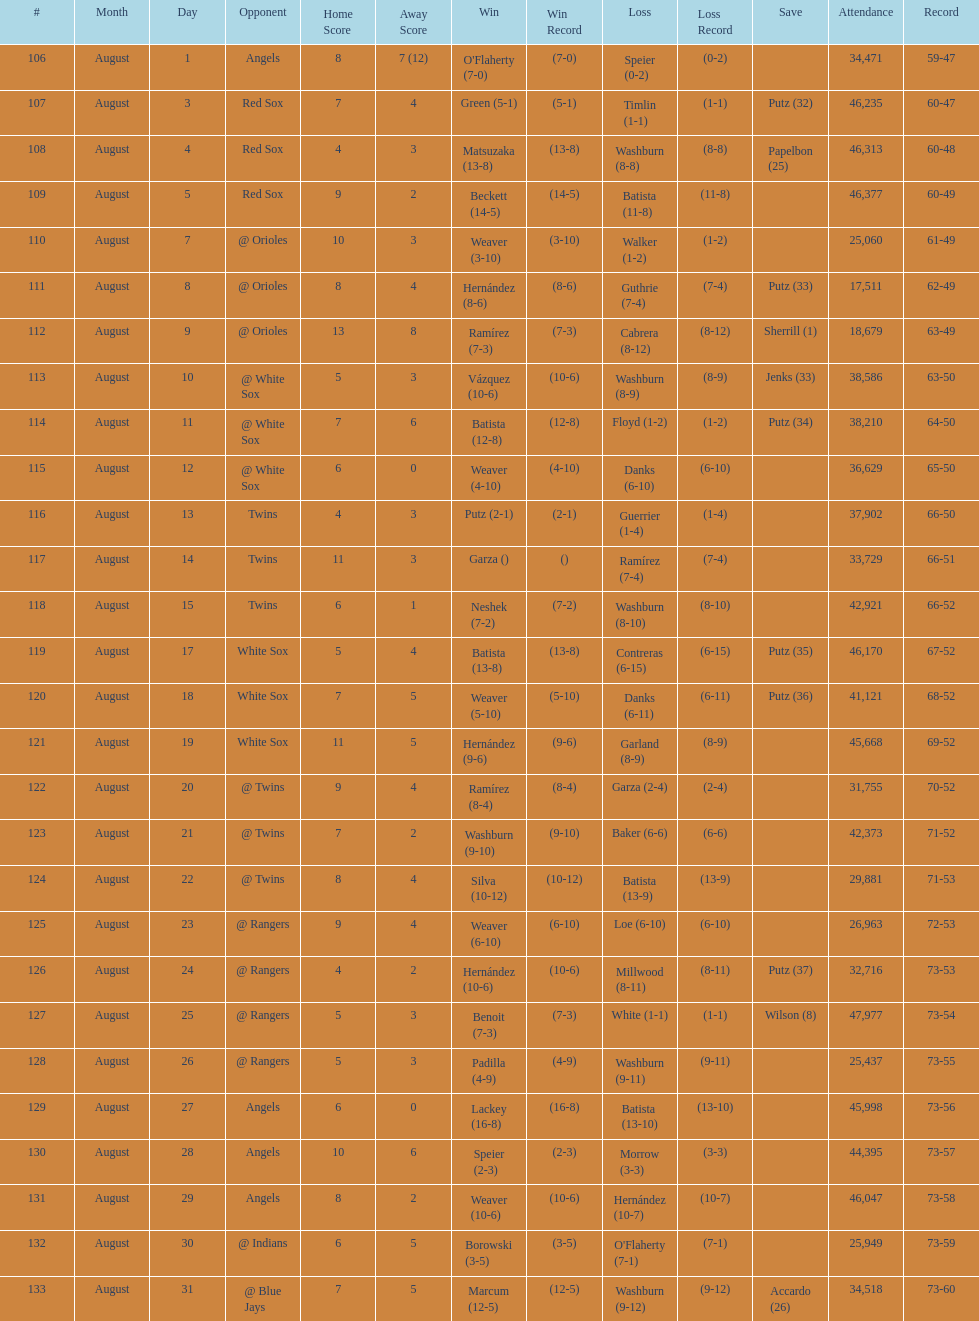Can you give me this table as a dict? {'header': ['#', 'Month', 'Day', 'Opponent', 'Home Score', 'Away Score', 'Win', 'Win Record', 'Loss', 'Loss Record', 'Save', 'Attendance', 'Record'], 'rows': [['106', 'August', '1', 'Angels', '8', '7 (12)', "O'Flaherty (7-0)", '(7-0)', 'Speier (0-2)', '(0-2)', '', '34,471', '59-47'], ['107', 'August', '3', 'Red Sox', '7', '4', 'Green (5-1)', '(5-1)', 'Timlin (1-1)', '(1-1)', 'Putz (32)', '46,235', '60-47'], ['108', 'August', '4', 'Red Sox', '4', '3', 'Matsuzaka (13-8)', '(13-8)', 'Washburn (8-8)', '(8-8)', 'Papelbon (25)', '46,313', '60-48'], ['109', 'August', '5', 'Red Sox', '9', '2', 'Beckett (14-5)', '(14-5)', 'Batista (11-8)', '(11-8)', '', '46,377', '60-49'], ['110', 'August', '7', '@ Orioles', '10', '3', 'Weaver (3-10)', '(3-10)', 'Walker (1-2)', '(1-2)', '', '25,060', '61-49'], ['111', 'August', '8', '@ Orioles', '8', '4', 'Hernández (8-6)', '(8-6)', 'Guthrie (7-4)', '(7-4)', 'Putz (33)', '17,511', '62-49'], ['112', 'August', '9', '@ Orioles', '13', '8', 'Ramírez (7-3)', '(7-3)', 'Cabrera (8-12)', '(8-12)', 'Sherrill (1)', '18,679', '63-49'], ['113', 'August', '10', '@ White Sox', '5', '3', 'Vázquez (10-6)', '(10-6)', 'Washburn (8-9)', '(8-9)', 'Jenks (33)', '38,586', '63-50'], ['114', 'August', '11', '@ White Sox', '7', '6', 'Batista (12-8)', '(12-8)', 'Floyd (1-2)', '(1-2)', 'Putz (34)', '38,210', '64-50'], ['115', 'August', '12', '@ White Sox', '6', '0', 'Weaver (4-10)', '(4-10)', 'Danks (6-10)', '(6-10)', '', '36,629', '65-50'], ['116', 'August', '13', 'Twins', '4', '3', 'Putz (2-1)', '(2-1)', 'Guerrier (1-4)', '(1-4)', '', '37,902', '66-50'], ['117', 'August', '14', 'Twins', '11', '3', 'Garza ()', '()', 'Ramírez (7-4)', '(7-4)', '', '33,729', '66-51'], ['118', 'August', '15', 'Twins', '6', '1', 'Neshek (7-2)', '(7-2)', 'Washburn (8-10)', '(8-10)', '', '42,921', '66-52'], ['119', 'August', '17', 'White Sox', '5', '4', 'Batista (13-8)', '(13-8)', 'Contreras (6-15)', '(6-15)', 'Putz (35)', '46,170', '67-52'], ['120', 'August', '18', 'White Sox', '7', '5', 'Weaver (5-10)', '(5-10)', 'Danks (6-11)', '(6-11)', 'Putz (36)', '41,121', '68-52'], ['121', 'August', '19', 'White Sox', '11', '5', 'Hernández (9-6)', '(9-6)', 'Garland (8-9)', '(8-9)', '', '45,668', '69-52'], ['122', 'August', '20', '@ Twins', '9', '4', 'Ramírez (8-4)', '(8-4)', 'Garza (2-4)', '(2-4)', '', '31,755', '70-52'], ['123', 'August', '21', '@ Twins', '7', '2', 'Washburn (9-10)', '(9-10)', 'Baker (6-6)', '(6-6)', '', '42,373', '71-52'], ['124', 'August', '22', '@ Twins', '8', '4', 'Silva (10-12)', '(10-12)', 'Batista (13-9)', '(13-9)', '', '29,881', '71-53'], ['125', 'August', '23', '@ Rangers', '9', '4', 'Weaver (6-10)', '(6-10)', 'Loe (6-10)', '(6-10)', '', '26,963', '72-53'], ['126', 'August', '24', '@ Rangers', '4', '2', 'Hernández (10-6)', '(10-6)', 'Millwood (8-11)', '(8-11)', 'Putz (37)', '32,716', '73-53'], ['127', 'August', '25', '@ Rangers', '5', '3', 'Benoit (7-3)', '(7-3)', 'White (1-1)', '(1-1)', 'Wilson (8)', '47,977', '73-54'], ['128', 'August', '26', '@ Rangers', '5', '3', 'Padilla (4-9)', '(4-9)', 'Washburn (9-11)', '(9-11)', '', '25,437', '73-55'], ['129', 'August', '27', 'Angels', '6', '0', 'Lackey (16-8)', '(16-8)', 'Batista (13-10)', '(13-10)', '', '45,998', '73-56'], ['130', 'August', '28', 'Angels', '10', '6', 'Speier (2-3)', '(2-3)', 'Morrow (3-3)', '(3-3)', '', '44,395', '73-57'], ['131', 'August', '29', 'Angels', '8', '2', 'Weaver (10-6)', '(10-6)', 'Hernández (10-7)', '(10-7)', '', '46,047', '73-58'], ['132', 'August', '30', '@ Indians', '6', '5', 'Borowski (3-5)', '(3-5)', "O'Flaherty (7-1)", '(7-1)', '', '25,949', '73-59'], ['133', 'August', '31', '@ Blue Jays', '7', '5', 'Marcum (12-5)', '(12-5)', 'Washburn (9-12)', '(9-12)', 'Accardo (26)', '34,518', '73-60']]} Games above 30,000 in attendance 21. 